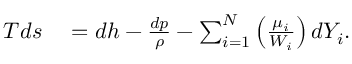<formula> <loc_0><loc_0><loc_500><loc_500>\begin{array} { r l } { T { d s } } & = d h - \frac { d p } { \rho } - \sum _ { i = 1 } ^ { N } \left ( \frac { \mu _ { i } } { W _ { i } } \right ) d Y _ { i } . } \end{array}</formula> 